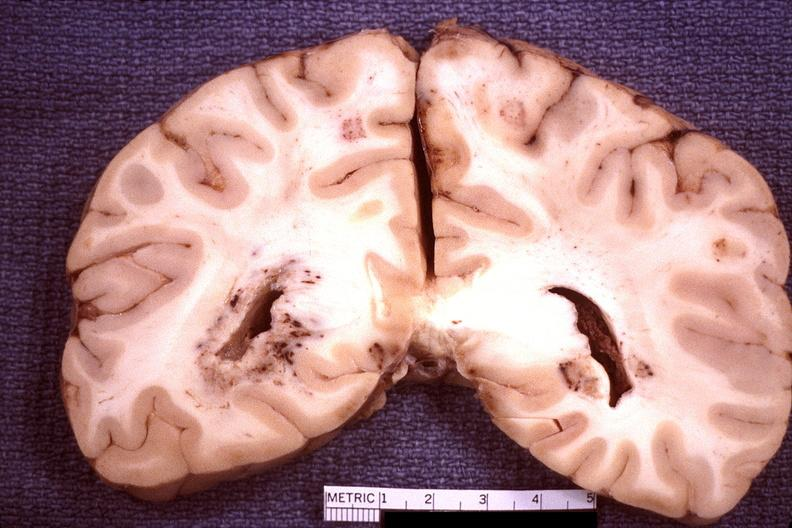s amputation stump infected present?
Answer the question using a single word or phrase. No 